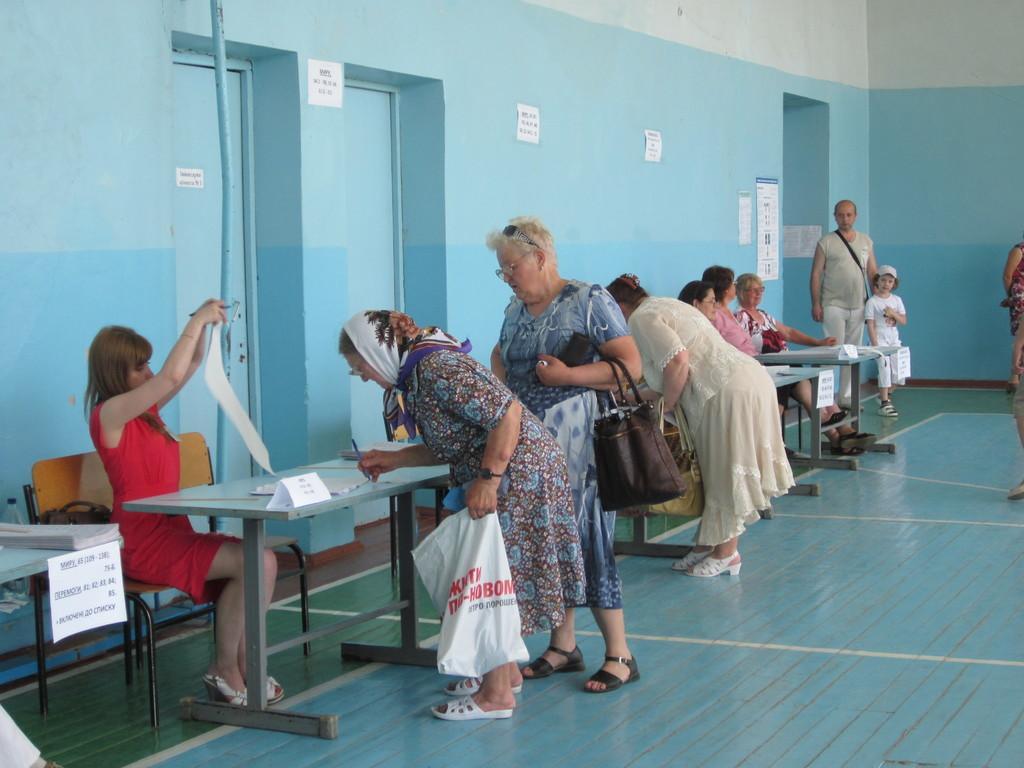How would you summarize this image in a sentence or two? In this image there are group of people, few are standing and few are sitting behind the table. There are papers, books on the table. At the back there are doors and there are posters on the wall. 